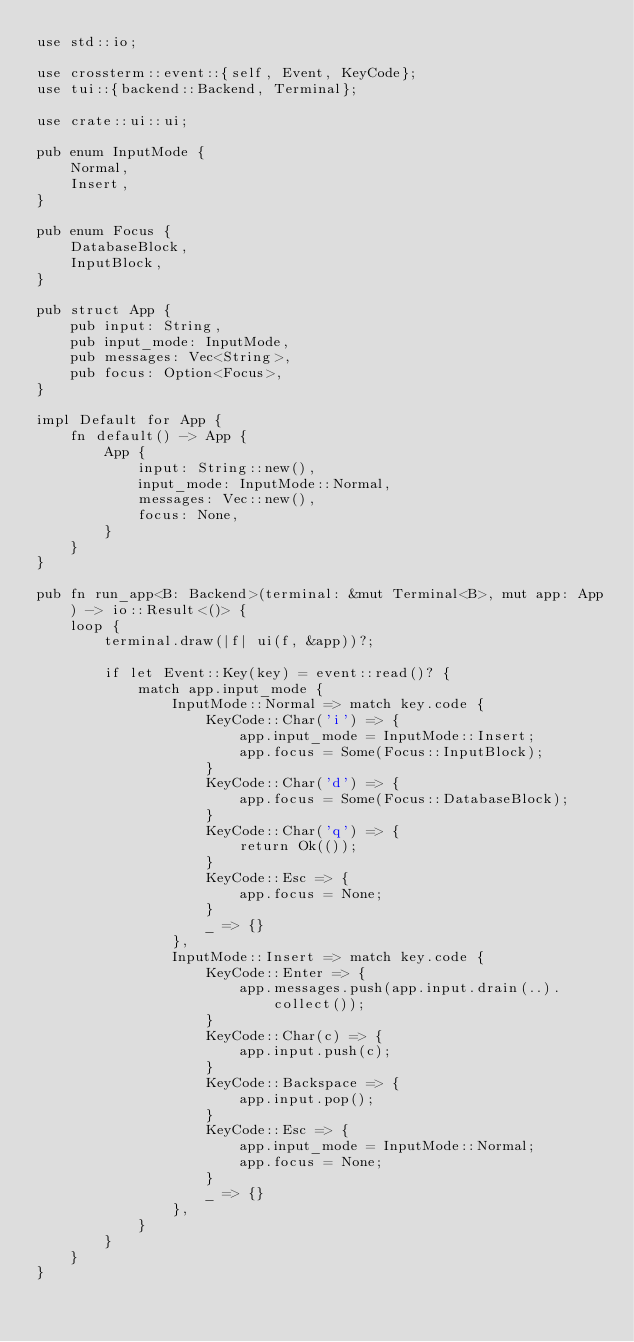<code> <loc_0><loc_0><loc_500><loc_500><_Rust_>use std::io;

use crossterm::event::{self, Event, KeyCode};
use tui::{backend::Backend, Terminal};

use crate::ui::ui;

pub enum InputMode {
    Normal,
    Insert,
}

pub enum Focus {
    DatabaseBlock,
    InputBlock,
}

pub struct App {
    pub input: String,
    pub input_mode: InputMode,
    pub messages: Vec<String>,
    pub focus: Option<Focus>,
}

impl Default for App {
    fn default() -> App {
        App {
            input: String::new(),
            input_mode: InputMode::Normal,
            messages: Vec::new(),
            focus: None,
        }
    }
}

pub fn run_app<B: Backend>(terminal: &mut Terminal<B>, mut app: App) -> io::Result<()> {
    loop {
        terminal.draw(|f| ui(f, &app))?;

        if let Event::Key(key) = event::read()? {
            match app.input_mode {
                InputMode::Normal => match key.code {
                    KeyCode::Char('i') => {
                        app.input_mode = InputMode::Insert;
                        app.focus = Some(Focus::InputBlock);
                    }
                    KeyCode::Char('d') => {
                        app.focus = Some(Focus::DatabaseBlock);
                    }
                    KeyCode::Char('q') => {
                        return Ok(());
                    }
                    KeyCode::Esc => {
                        app.focus = None;
                    }
                    _ => {}
                },
                InputMode::Insert => match key.code {
                    KeyCode::Enter => {
                        app.messages.push(app.input.drain(..).collect());
                    }
                    KeyCode::Char(c) => {
                        app.input.push(c);
                    }
                    KeyCode::Backspace => {
                        app.input.pop();
                    }
                    KeyCode::Esc => {
                        app.input_mode = InputMode::Normal;
                        app.focus = None;
                    }
                    _ => {}
                },
            }
        }
    }
}
</code> 